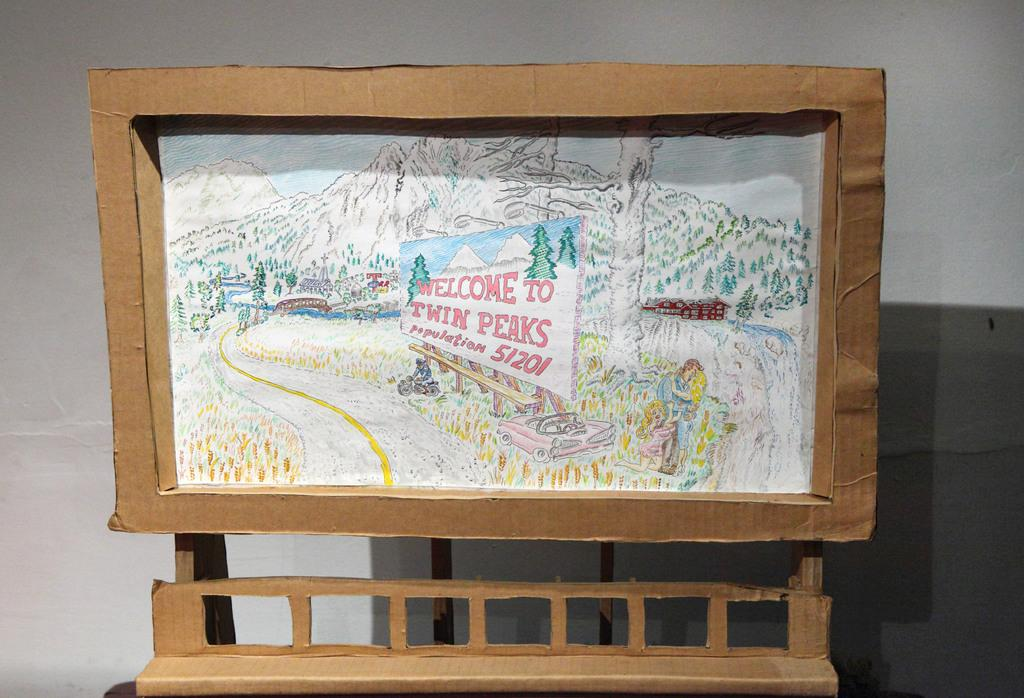<image>
Relay a brief, clear account of the picture shown. Winter scene with Welcome to Twin Peaks in a cardboard frame! 